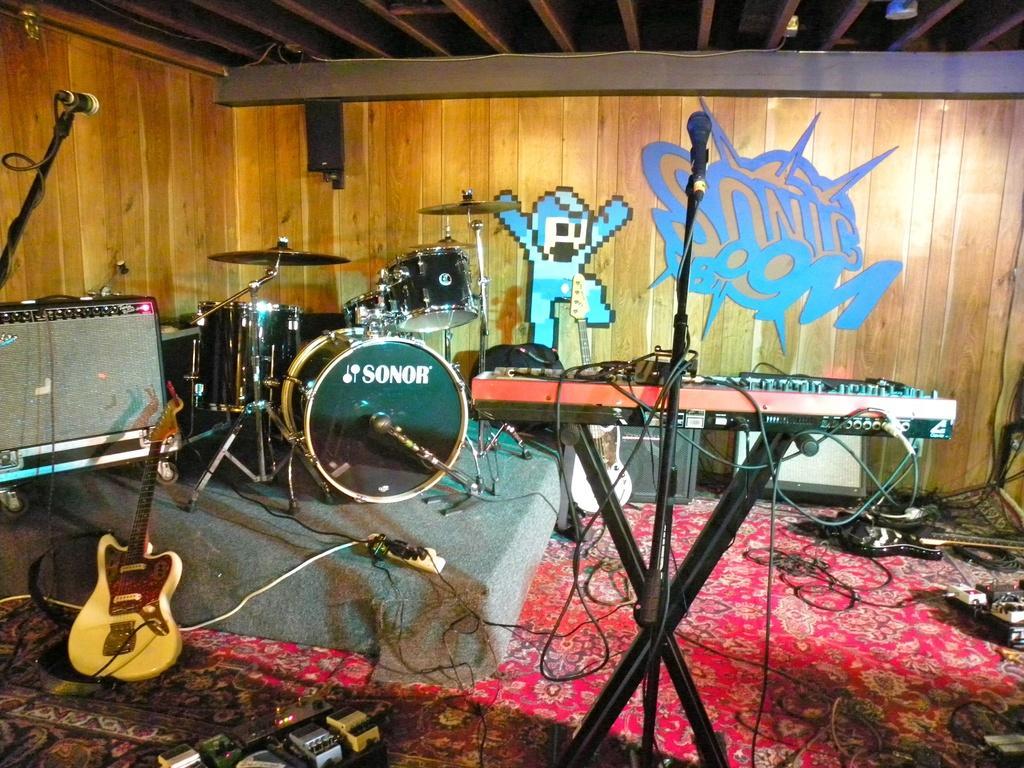How would you summarize this image in a sentence or two? This is the picture of a room where we have different types of musical instruments in the room and some speakers and some posters to the wall. 